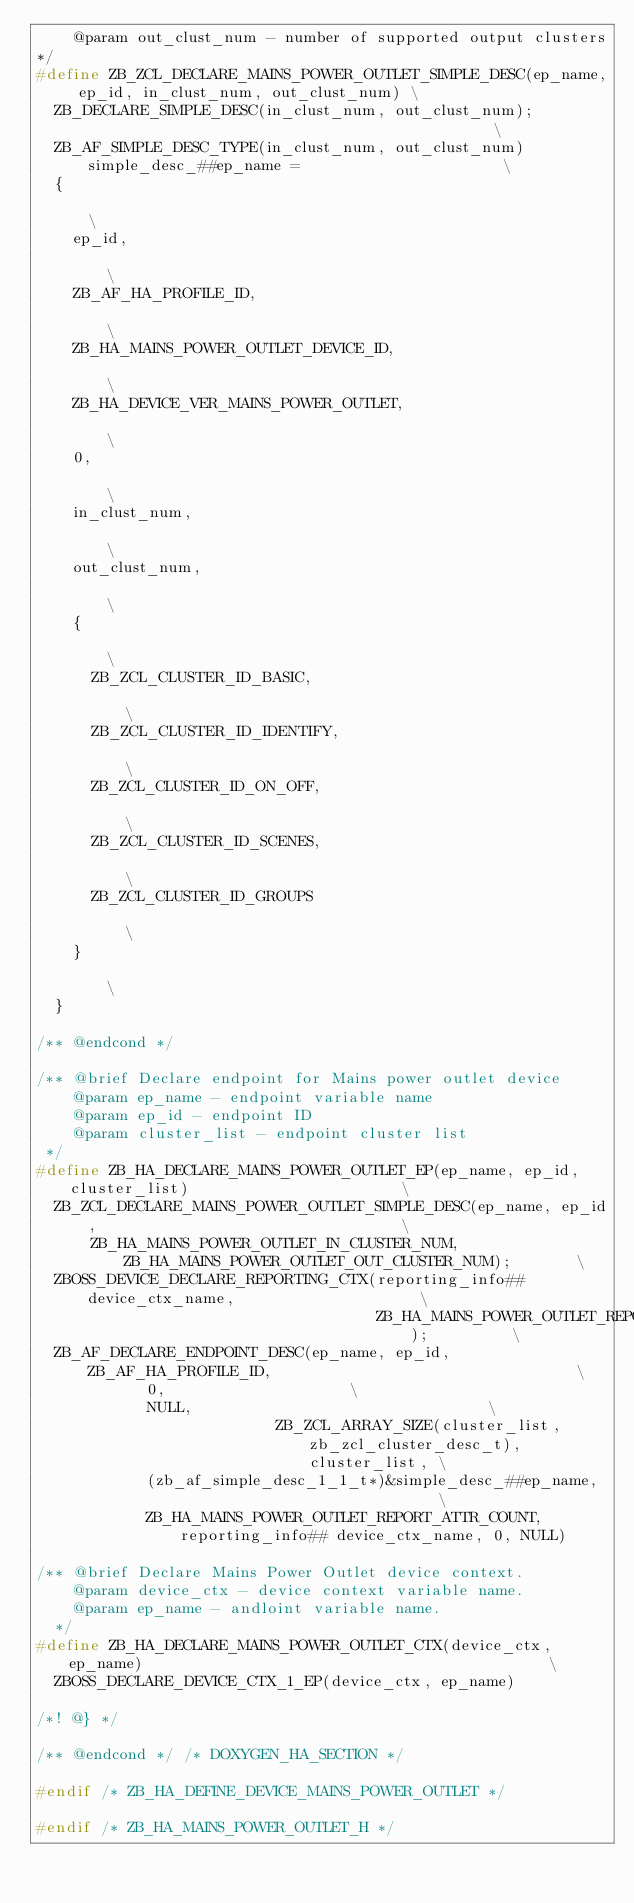Convert code to text. <code><loc_0><loc_0><loc_500><loc_500><_C_>    @param out_clust_num - number of supported output clusters
*/
#define ZB_ZCL_DECLARE_MAINS_POWER_OUTLET_SIMPLE_DESC(ep_name, ep_id, in_clust_num, out_clust_num) \
  ZB_DECLARE_SIMPLE_DESC(in_clust_num, out_clust_num);                                             \
  ZB_AF_SIMPLE_DESC_TYPE(in_clust_num, out_clust_num) simple_desc_##ep_name =                      \
  {                                                                                                \
    ep_id,                                                                                         \
    ZB_AF_HA_PROFILE_ID,                                                                           \
    ZB_HA_MAINS_POWER_OUTLET_DEVICE_ID,                                                            \
    ZB_HA_DEVICE_VER_MAINS_POWER_OUTLET,                                                           \
    0,                                                                                             \
    in_clust_num,                                                                                  \
    out_clust_num,                                                                                 \
    {                                                                                              \
      ZB_ZCL_CLUSTER_ID_BASIC,                                                                     \
      ZB_ZCL_CLUSTER_ID_IDENTIFY,                                                                  \
      ZB_ZCL_CLUSTER_ID_ON_OFF,                                                                    \
      ZB_ZCL_CLUSTER_ID_SCENES,                                                                    \
      ZB_ZCL_CLUSTER_ID_GROUPS                                                                     \
    }                                                                                              \
  }

/** @endcond */

/** @brief Declare endpoint for Mains power outlet device
    @param ep_name - endpoint variable name
    @param ep_id - endpoint ID
    @param cluster_list - endpoint cluster list
 */
#define ZB_HA_DECLARE_MAINS_POWER_OUTLET_EP(ep_name, ep_id, cluster_list)                       \
  ZB_ZCL_DECLARE_MAINS_POWER_OUTLET_SIMPLE_DESC(ep_name, ep_id,                                 \
      ZB_HA_MAINS_POWER_OUTLET_IN_CLUSTER_NUM, ZB_HA_MAINS_POWER_OUTLET_OUT_CLUSTER_NUM);       \
  ZBOSS_DEVICE_DECLARE_REPORTING_CTX(reporting_info## device_ctx_name,                    \
                                     ZB_HA_MAINS_POWER_OUTLET_REPORT_ATTR_COUNT);         \
  ZB_AF_DECLARE_ENDPOINT_DESC(ep_name, ep_id, ZB_AF_HA_PROFILE_ID,                                 \
            0,                    \
            NULL,                                \
                          ZB_ZCL_ARRAY_SIZE(cluster_list, zb_zcl_cluster_desc_t), cluster_list, \
            (zb_af_simple_desc_1_1_t*)&simple_desc_##ep_name,                             \
            ZB_HA_MAINS_POWER_OUTLET_REPORT_ATTR_COUNT, reporting_info## device_ctx_name, 0, NULL)

/** @brief Declare Mains Power Outlet device context.
    @param device_ctx - device context variable name.
    @param ep_name - andloint variable name.
  */
#define ZB_HA_DECLARE_MAINS_POWER_OUTLET_CTX(device_ctx, ep_name)                                            \
  ZBOSS_DECLARE_DEVICE_CTX_1_EP(device_ctx, ep_name)

/*! @} */

/** @endcond */ /* DOXYGEN_HA_SECTION */

#endif /* ZB_HA_DEFINE_DEVICE_MAINS_POWER_OUTLET */

#endif /* ZB_HA_MAINS_POWER_OUTLET_H */
</code> 